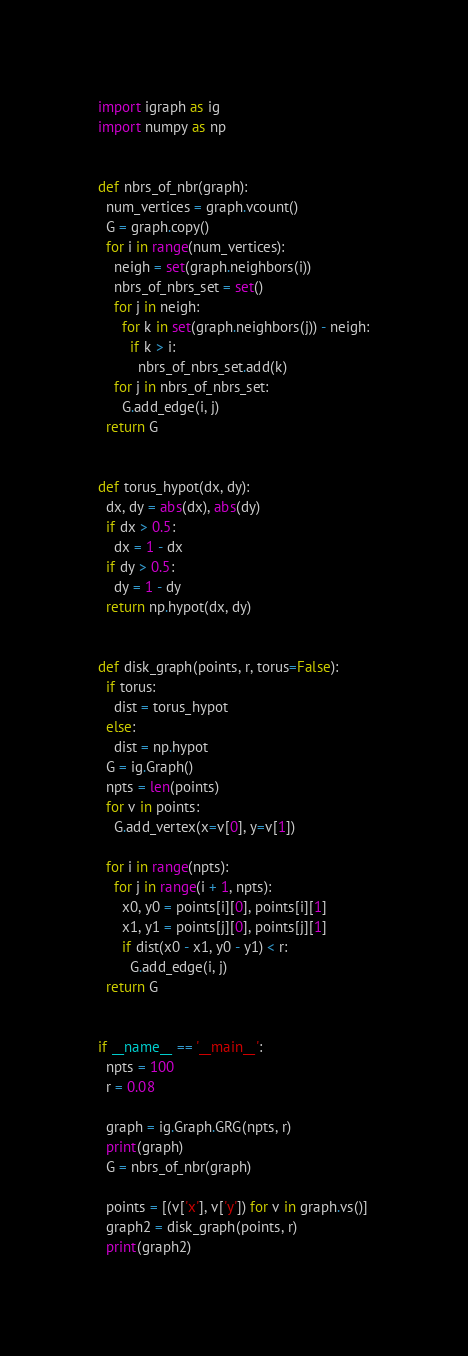<code> <loc_0><loc_0><loc_500><loc_500><_Python_>import igraph as ig
import numpy as np


def nbrs_of_nbr(graph):
  num_vertices = graph.vcount()
  G = graph.copy()
  for i in range(num_vertices):
    neigh = set(graph.neighbors(i))
    nbrs_of_nbrs_set = set()
    for j in neigh:
      for k in set(graph.neighbors(j)) - neigh:
        if k > i:
          nbrs_of_nbrs_set.add(k)
    for j in nbrs_of_nbrs_set:
      G.add_edge(i, j)
  return G


def torus_hypot(dx, dy):
  dx, dy = abs(dx), abs(dy)
  if dx > 0.5:
    dx = 1 - dx
  if dy > 0.5:
    dy = 1 - dy
  return np.hypot(dx, dy)


def disk_graph(points, r, torus=False):
  if torus:
    dist = torus_hypot
  else:
    dist = np.hypot
  G = ig.Graph()
  npts = len(points)
  for v in points:
    G.add_vertex(x=v[0], y=v[1])

  for i in range(npts):
    for j in range(i + 1, npts):
      x0, y0 = points[i][0], points[i][1]
      x1, y1 = points[j][0], points[j][1]
      if dist(x0 - x1, y0 - y1) < r:
        G.add_edge(i, j)
  return G


if __name__ == '__main__':
  npts = 100
  r = 0.08

  graph = ig.Graph.GRG(npts, r)
  print(graph)
  G = nbrs_of_nbr(graph)

  points = [(v['x'], v['y']) for v in graph.vs()]
  graph2 = disk_graph(points, r)
  print(graph2)
</code> 